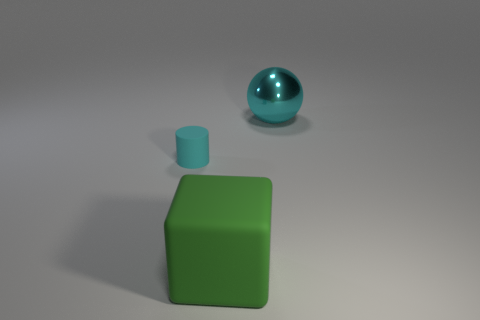What is the object in front of the object to the left of the big rubber cube made of?
Offer a terse response. Rubber. Are there fewer tiny cyan rubber objects left of the tiny cyan object than big cyan things that are to the right of the big metal object?
Provide a succinct answer. No. What number of cyan things are either large rubber things or large metallic things?
Your answer should be very brief. 1. Are there an equal number of cyan rubber cylinders that are behind the metal thing and matte blocks?
Ensure brevity in your answer.  No. How many things are cyan metal objects or big things that are on the left side of the large cyan shiny sphere?
Provide a succinct answer. 2. Do the big metal ball and the matte block have the same color?
Give a very brief answer. No. Is there a green block that has the same material as the big cyan sphere?
Your answer should be very brief. No. Is the green cube made of the same material as the cyan thing in front of the cyan metal ball?
Your answer should be compact. Yes. There is a thing that is in front of the cyan object that is to the left of the large ball; what is its shape?
Offer a terse response. Cube. There is a cyan object in front of the ball; is it the same size as the matte cube?
Make the answer very short. No. 